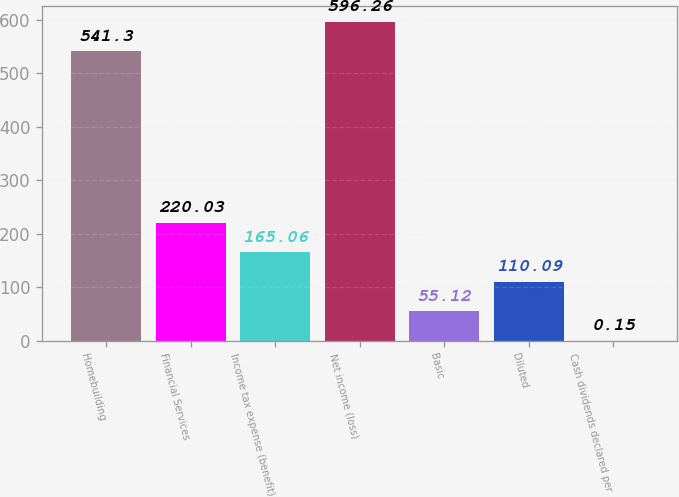Convert chart to OTSL. <chart><loc_0><loc_0><loc_500><loc_500><bar_chart><fcel>Homebuilding<fcel>Financial Services<fcel>Income tax expense (benefit)<fcel>Net income (loss)<fcel>Basic<fcel>Diluted<fcel>Cash dividends declared per<nl><fcel>541.3<fcel>220.03<fcel>165.06<fcel>596.26<fcel>55.12<fcel>110.09<fcel>0.15<nl></chart> 